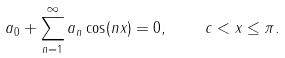<formula> <loc_0><loc_0><loc_500><loc_500>a _ { 0 } + \sum ^ { \infty } _ { n = 1 } a _ { n } \cos ( n x ) = 0 , \quad c < x \leq \pi .</formula> 